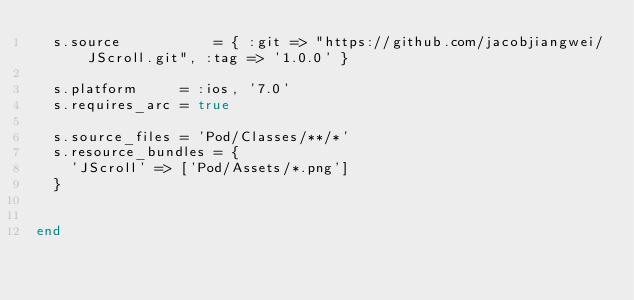<code> <loc_0><loc_0><loc_500><loc_500><_Ruby_>  s.source           = { :git => "https://github.com/jacobjiangwei/JScroll.git", :tag => '1.0.0' }

  s.platform     = :ios, '7.0'
  s.requires_arc = true

  s.source_files = 'Pod/Classes/**/*'
  s.resource_bundles = {
    'JScroll' => ['Pod/Assets/*.png']
  }


end
</code> 